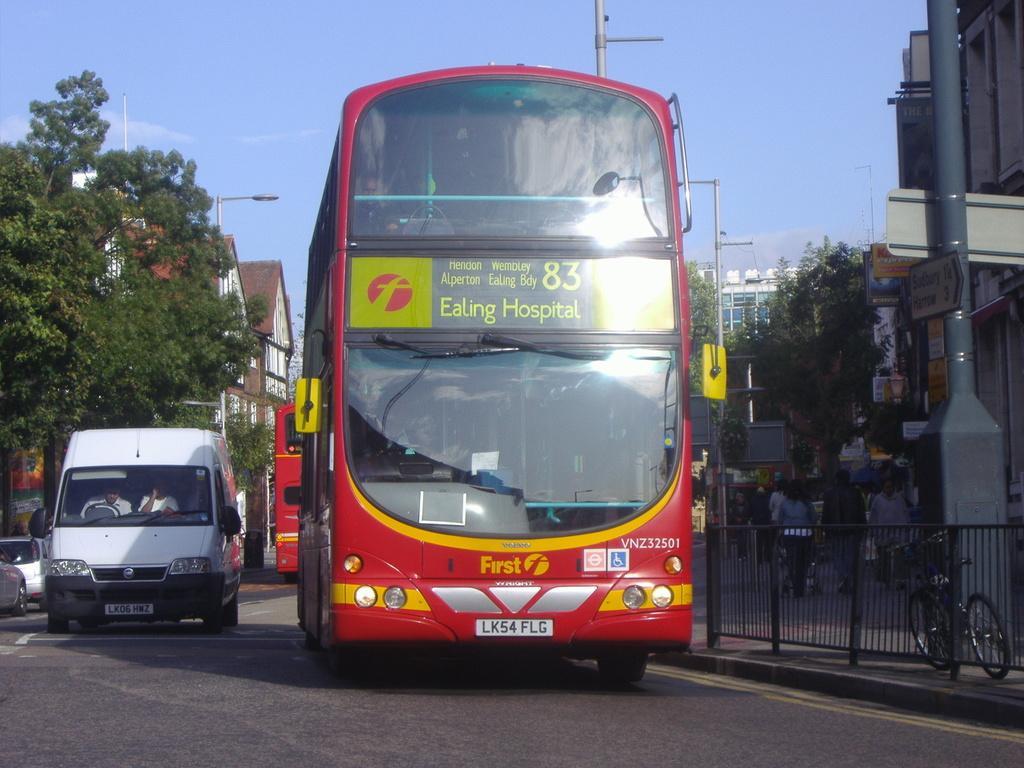Can you describe this image briefly? In the center of the image there are vehicles on the road. On the right side of the image there is a metal fence. There is a cycle. There are poles. On the left side of the image there is a street light. On the right side of the image there are people walking on the pavement. There are sign boards. In the background of the image there are trees, buildings and sky. 